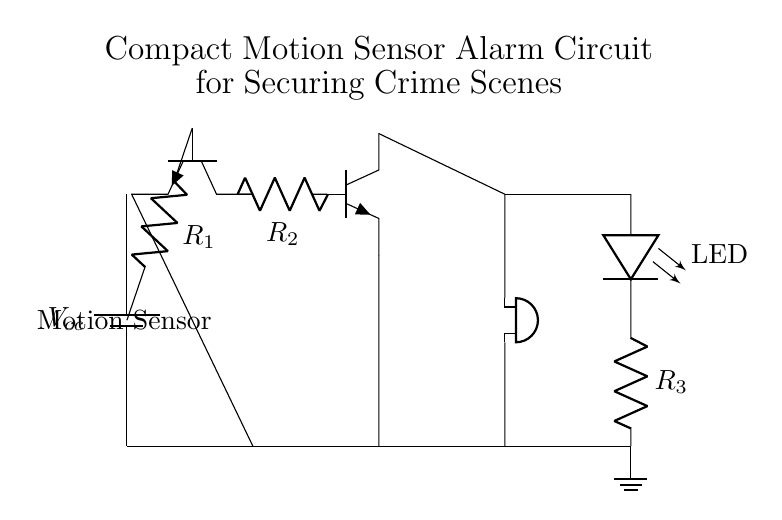What type of transistor is used in this circuit? The circuit uses two npn transistors, which are indicated by the npn symbol in the diagram. They are crucial for amplifying the signal from the motion sensor.
Answer: npn What does the motion sensor do in this circuit? The motion sensor detects movement in the area, which triggers the transistor to send a signal to the buzzer and LED. It is placed at the beginning of the circuit to initiate the alarm process.
Answer: Detects movement What is the purpose of resistor R1? Resistor R1 is connected to the base of the first transistor and helps to limit the current flowing into the base, ensuring proper transistor operation without overloading it.
Answer: Current limiting Which component indicates that the alarm is active? The buzzer is the component that actively indicates alarm status when triggered by the signal from the transistors.
Answer: Buzzer Why are there two transistors in this circuit? The first transistor (Q1) amplifies the signal from the motion sensor, and the second transistor (Q2) further strengthens to drive the buzzer and LED, making the alarm system more responsive.
Answer: Signal amplification What is the role of the LED in this circuit? The LED serves as a visual indicator that the alarm is active, providing a feedback mechanism to show that the system is detecting motion and the alarm is functioning.
Answer: Visual indicator 